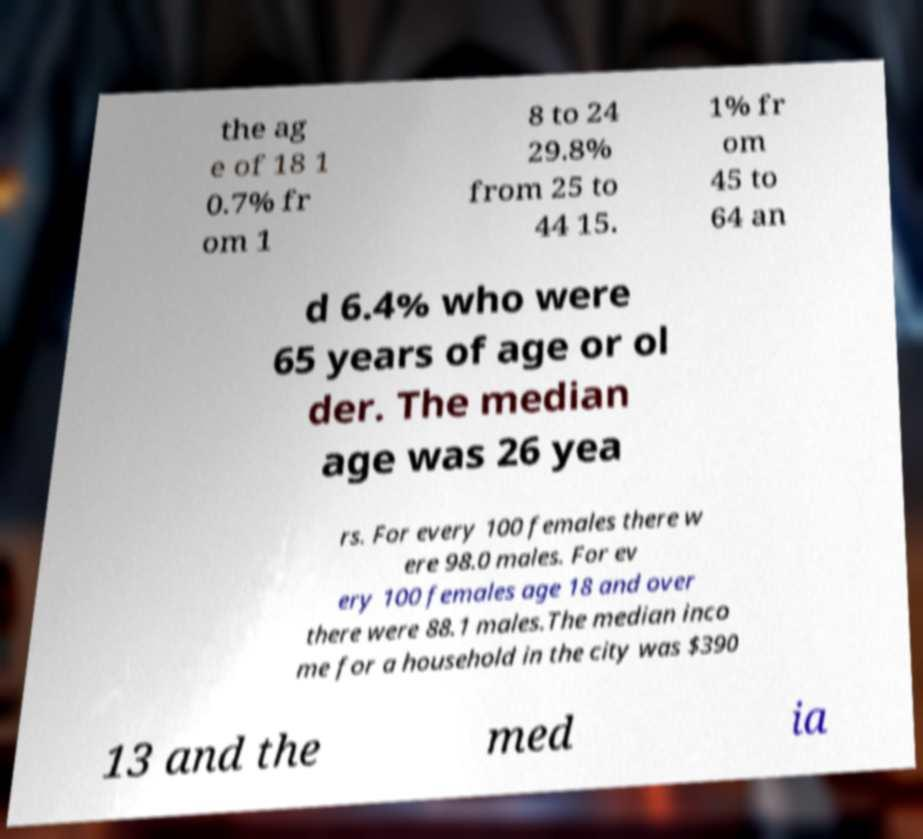Can you accurately transcribe the text from the provided image for me? the ag e of 18 1 0.7% fr om 1 8 to 24 29.8% from 25 to 44 15. 1% fr om 45 to 64 an d 6.4% who were 65 years of age or ol der. The median age was 26 yea rs. For every 100 females there w ere 98.0 males. For ev ery 100 females age 18 and over there were 88.1 males.The median inco me for a household in the city was $390 13 and the med ia 